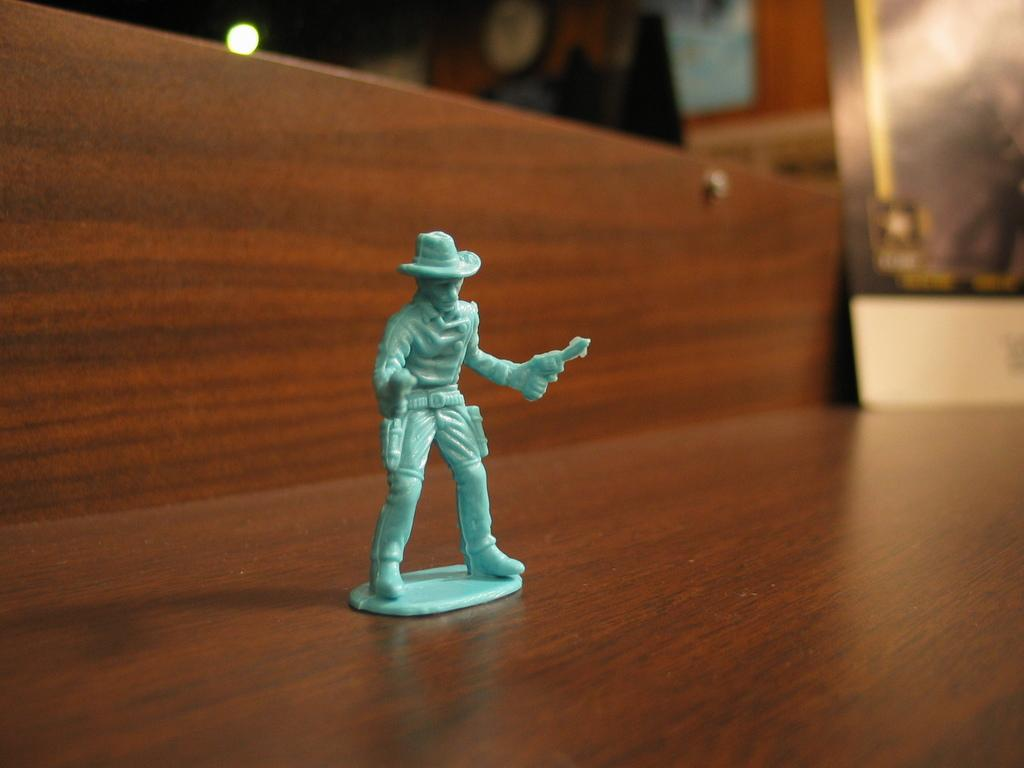What type of object is green in color in the image? There is a green-colored toy in the image. Can you describe the quality of the background in the image? The image is blurry in the background. How many kittens are peacefully playing with the green-colored toy in the image? There are no kittens present in the image, and the green-colored toy is not associated with any activity involving kittens. 